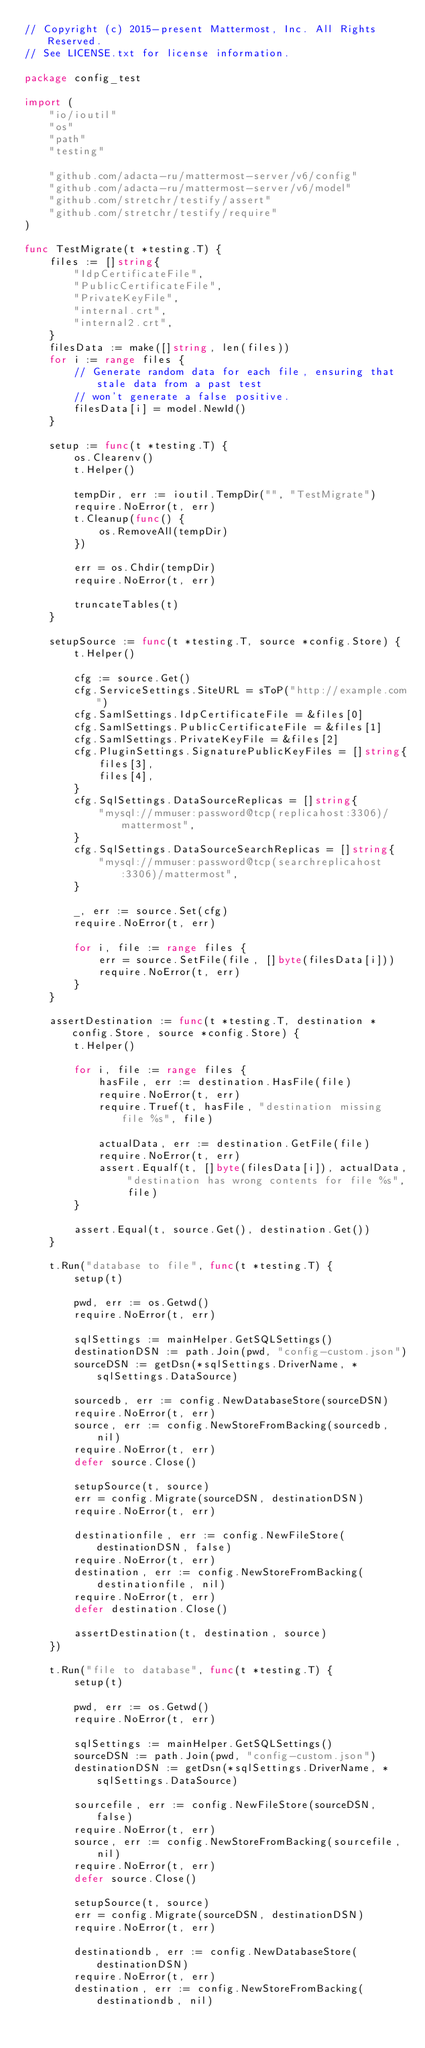<code> <loc_0><loc_0><loc_500><loc_500><_Go_>// Copyright (c) 2015-present Mattermost, Inc. All Rights Reserved.
// See LICENSE.txt for license information.

package config_test

import (
	"io/ioutil"
	"os"
	"path"
	"testing"

	"github.com/adacta-ru/mattermost-server/v6/config"
	"github.com/adacta-ru/mattermost-server/v6/model"
	"github.com/stretchr/testify/assert"
	"github.com/stretchr/testify/require"
)

func TestMigrate(t *testing.T) {
	files := []string{
		"IdpCertificateFile",
		"PublicCertificateFile",
		"PrivateKeyFile",
		"internal.crt",
		"internal2.crt",
	}
	filesData := make([]string, len(files))
	for i := range files {
		// Generate random data for each file, ensuring that stale data from a past test
		// won't generate a false positive.
		filesData[i] = model.NewId()
	}

	setup := func(t *testing.T) {
		os.Clearenv()
		t.Helper()

		tempDir, err := ioutil.TempDir("", "TestMigrate")
		require.NoError(t, err)
		t.Cleanup(func() {
			os.RemoveAll(tempDir)
		})

		err = os.Chdir(tempDir)
		require.NoError(t, err)

		truncateTables(t)
	}

	setupSource := func(t *testing.T, source *config.Store) {
		t.Helper()

		cfg := source.Get()
		cfg.ServiceSettings.SiteURL = sToP("http://example.com")
		cfg.SamlSettings.IdpCertificateFile = &files[0]
		cfg.SamlSettings.PublicCertificateFile = &files[1]
		cfg.SamlSettings.PrivateKeyFile = &files[2]
		cfg.PluginSettings.SignaturePublicKeyFiles = []string{
			files[3],
			files[4],
		}
		cfg.SqlSettings.DataSourceReplicas = []string{
			"mysql://mmuser:password@tcp(replicahost:3306)/mattermost",
		}
		cfg.SqlSettings.DataSourceSearchReplicas = []string{
			"mysql://mmuser:password@tcp(searchreplicahost:3306)/mattermost",
		}

		_, err := source.Set(cfg)
		require.NoError(t, err)

		for i, file := range files {
			err = source.SetFile(file, []byte(filesData[i]))
			require.NoError(t, err)
		}
	}

	assertDestination := func(t *testing.T, destination *config.Store, source *config.Store) {
		t.Helper()

		for i, file := range files {
			hasFile, err := destination.HasFile(file)
			require.NoError(t, err)
			require.Truef(t, hasFile, "destination missing file %s", file)

			actualData, err := destination.GetFile(file)
			require.NoError(t, err)
			assert.Equalf(t, []byte(filesData[i]), actualData, "destination has wrong contents for file %s", file)
		}

		assert.Equal(t, source.Get(), destination.Get())
	}

	t.Run("database to file", func(t *testing.T) {
		setup(t)

		pwd, err := os.Getwd()
		require.NoError(t, err)

		sqlSettings := mainHelper.GetSQLSettings()
		destinationDSN := path.Join(pwd, "config-custom.json")
		sourceDSN := getDsn(*sqlSettings.DriverName, *sqlSettings.DataSource)

		sourcedb, err := config.NewDatabaseStore(sourceDSN)
		require.NoError(t, err)
		source, err := config.NewStoreFromBacking(sourcedb, nil)
		require.NoError(t, err)
		defer source.Close()

		setupSource(t, source)
		err = config.Migrate(sourceDSN, destinationDSN)
		require.NoError(t, err)

		destinationfile, err := config.NewFileStore(destinationDSN, false)
		require.NoError(t, err)
		destination, err := config.NewStoreFromBacking(destinationfile, nil)
		require.NoError(t, err)
		defer destination.Close()

		assertDestination(t, destination, source)
	})

	t.Run("file to database", func(t *testing.T) {
		setup(t)

		pwd, err := os.Getwd()
		require.NoError(t, err)

		sqlSettings := mainHelper.GetSQLSettings()
		sourceDSN := path.Join(pwd, "config-custom.json")
		destinationDSN := getDsn(*sqlSettings.DriverName, *sqlSettings.DataSource)

		sourcefile, err := config.NewFileStore(sourceDSN, false)
		require.NoError(t, err)
		source, err := config.NewStoreFromBacking(sourcefile, nil)
		require.NoError(t, err)
		defer source.Close()

		setupSource(t, source)
		err = config.Migrate(sourceDSN, destinationDSN)
		require.NoError(t, err)

		destinationdb, err := config.NewDatabaseStore(destinationDSN)
		require.NoError(t, err)
		destination, err := config.NewStoreFromBacking(destinationdb, nil)</code> 